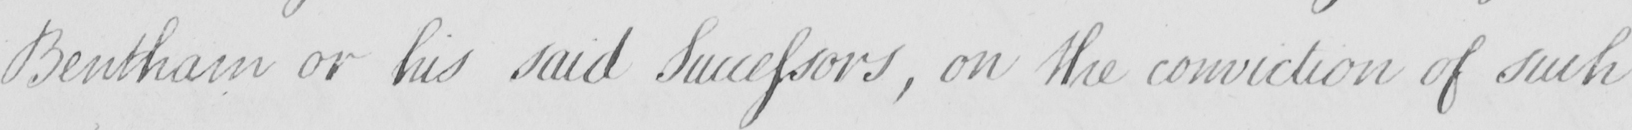Can you tell me what this handwritten text says? Bentham or his said Successors , on the conviction of such 